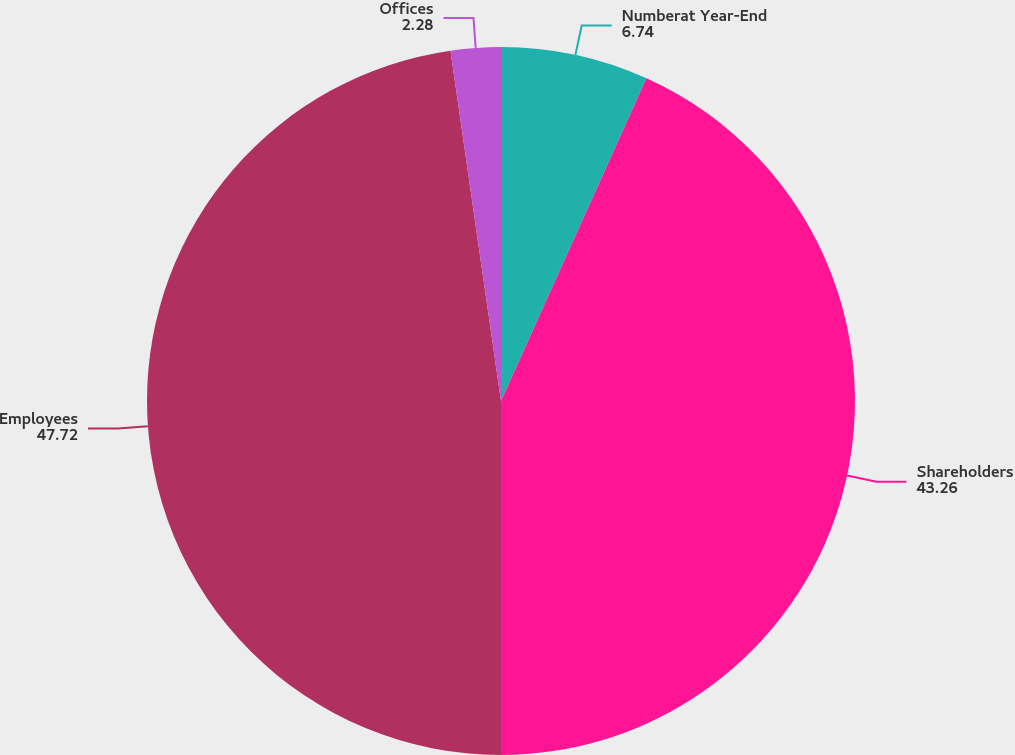Convert chart. <chart><loc_0><loc_0><loc_500><loc_500><pie_chart><fcel>Numberat Year-End<fcel>Shareholders<fcel>Employees<fcel>Offices<nl><fcel>6.74%<fcel>43.26%<fcel>47.72%<fcel>2.28%<nl></chart> 